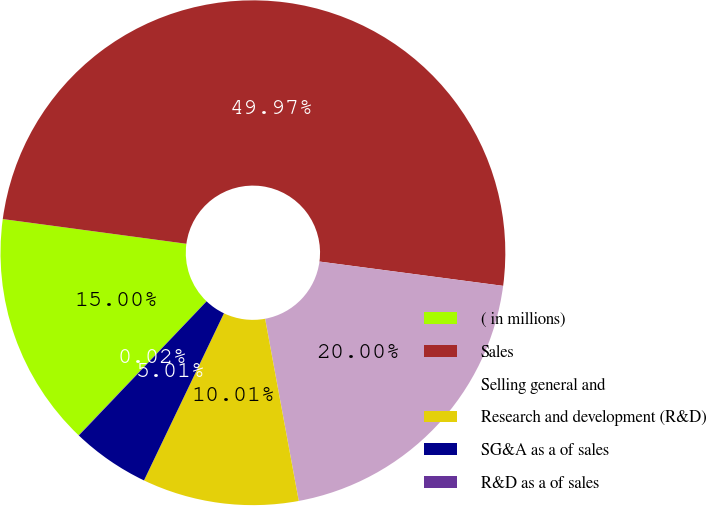Convert chart to OTSL. <chart><loc_0><loc_0><loc_500><loc_500><pie_chart><fcel>( in millions)<fcel>Sales<fcel>Selling general and<fcel>Research and development (R&D)<fcel>SG&A as a of sales<fcel>R&D as a of sales<nl><fcel>15.0%<fcel>49.97%<fcel>20.0%<fcel>10.01%<fcel>5.01%<fcel>0.02%<nl></chart> 